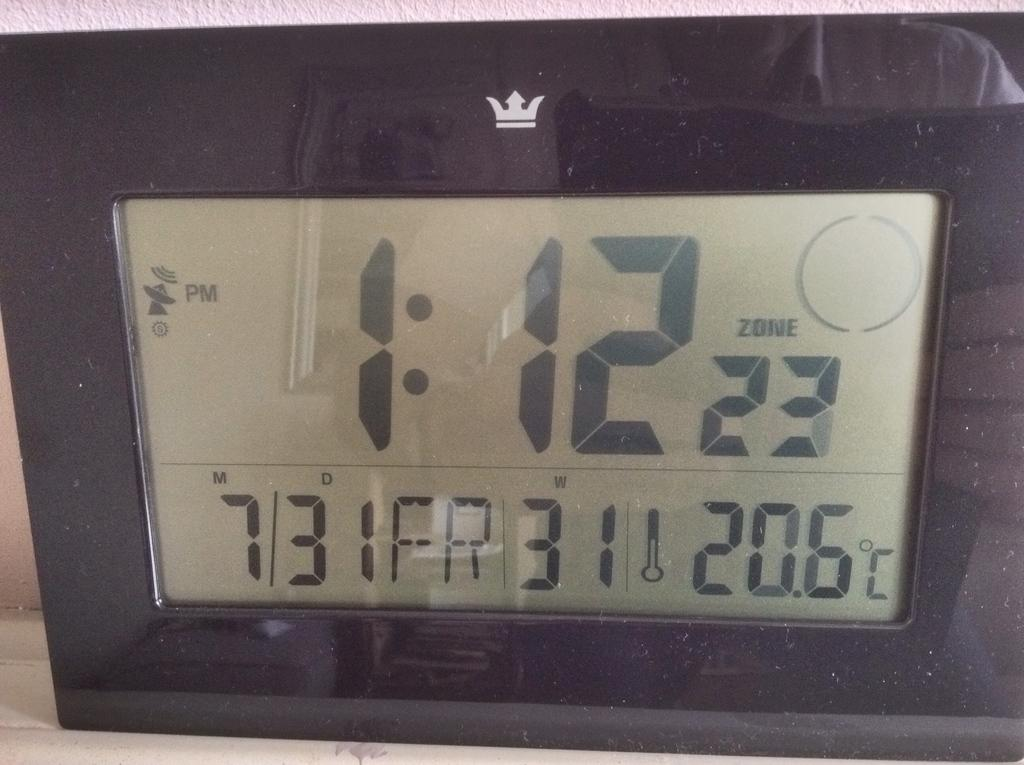<image>
Render a clear and concise summary of the photo. a clock with a small crown at the top saying it's 1:12 PM 